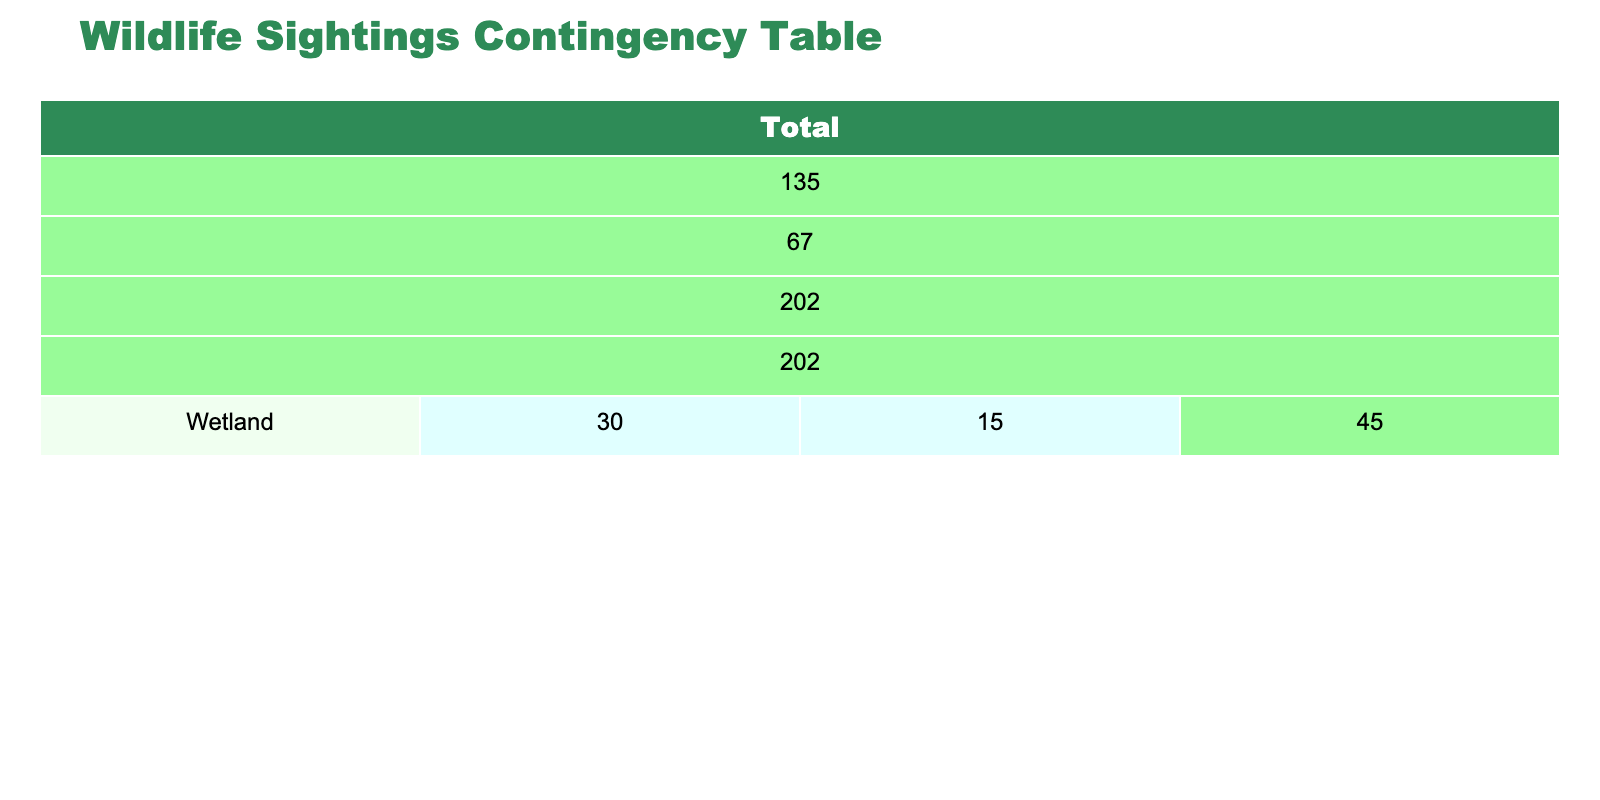What is the total number of wildlife sightings in Wetland after restoration? From the table, in the Wetland habitat type, the number of sightings after restoration is listed as 30. Therefore, the total number of sightings after restoration in Wetland is 30.
Answer: 30 How many more wildlife sightings were observed in the Forest after restoration compared to before? To find the difference, we look at the Forest habitat type: the number of sightings before restoration is 25, and after is 50. The difference is 50 - 25 = 25.
Answer: 25 Is the total number of wildlife sightings in Urban Area higher before or after restoration? In the Urban Area, the number of sightings before restoration is 5 and after restoration is 10. Since 10 is greater than 5, the total number of sightings is higher after restoration.
Answer: Yes What is the average number of wildlife sightings for Grassland before and after restoration? The sightings for Grassland before restoration is 10 and after is 20. To calculate the average, we sum these values (10 + 20 = 30) and divide by the total number of observations, which is 2. The average is 30 / 2 = 15.
Answer: 15 What is the total number of wildlife sightings across all habitat types before restoration? By summing the number of sightings before restoration from all habitat types: Wetland (15) + Forest (25) + Grassland (10) + Urban Area (5) + Riparian Zone (12) = 67. Thus, the total number of sightings before restoration is 67.
Answer: 67 How many wildlife sightings were observed in Riparian Zone after restoration compared to Urban Area after restoration? For Riparian Zone after restoration, there are 25 sightings and for Urban Area, there are 10 sightings. By comparing, 25 is greater than 10. Therefore, more sightings were observed in Riparian Zone after restoration.
Answer: Yes Which habitat type saw the highest increase in wildlife sightings from before to after restoration? The increase in sightings is calculated for each habitat type: Wetland (30 - 15 = 15), Forest (50 - 25 = 25), Grassland (20 - 10 = 10), Urban Area (10 - 5 = 5), and Riparian Zone (25 - 12 = 13). The highest increase is 25 for Forest.
Answer: Forest What is the total number of wildlife sightings after restoration? To find the total after restoration, we sum the sightings: Wetland (30) + Forest (50) + Grassland (20) + Urban Area (10) + Riparian Zone (25) = 135. Therefore, the total number of sightings after restoration is 135.
Answer: 135 How many more sightings were observed in Riparian Zone after restoration compared to Wetland after restoration? In Riparian Zone after restoration, there are 25 sightings, and in Wetland after restoration, there are 30 sightings. The difference is 25 - 30 = -5, indicating there were fewer sightings in Riparian Zone compared to Wetland after restoration.
Answer: -5 